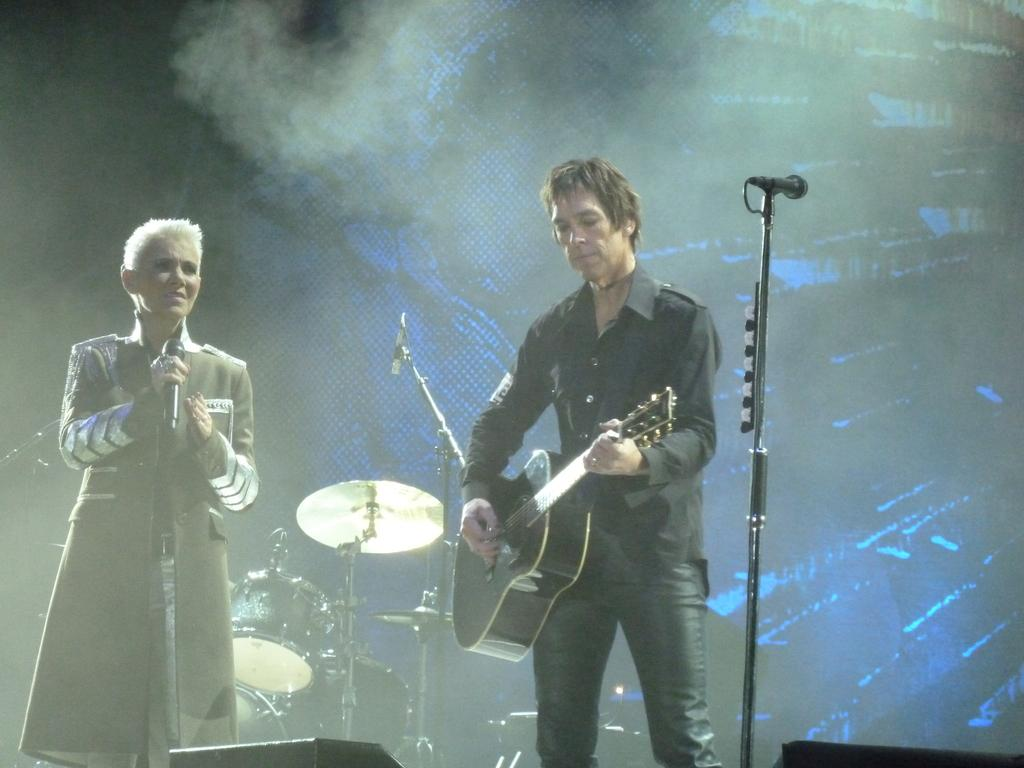How many people are in the image? There are two persons standing in the image. What are the people holding in the image? One person is holding a guitar, and the other person is holding a microphone. Can you describe the microphone setup in the image? There is a microphone with a stand in the image. What else can be seen in the image related to music? Musical instruments are visible in the background of the image. What book is the person reading at their birthday party with their uncle? There is no book, birthday party, or uncle present in the image. The image features two people, one holding a guitar and the other holding a microphone, with a microphone stand and musical instruments in the background. 